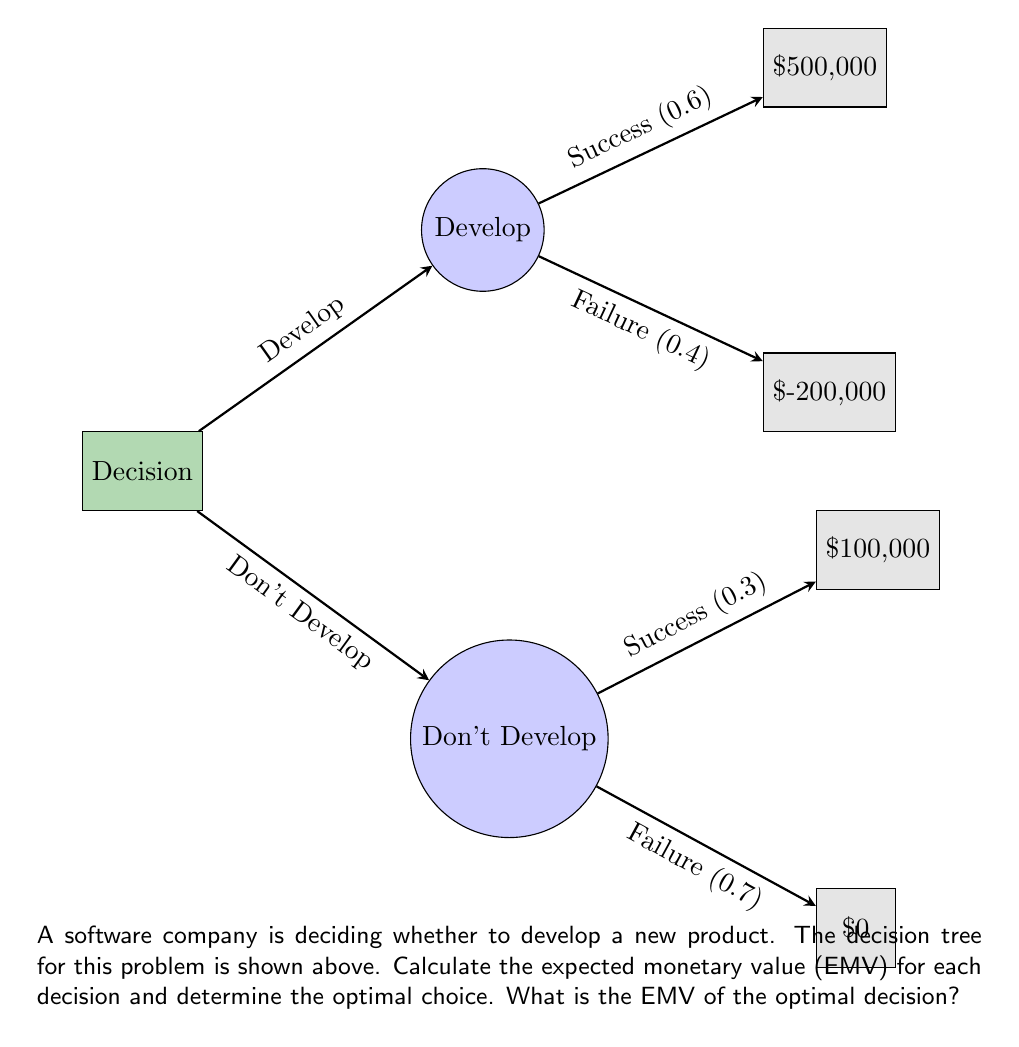Show me your answer to this math problem. Let's solve this problem step by step using the decision tree analysis:

1) First, we need to calculate the EMV for the "Develop" branch:

   a) If they develop and succeed (probability 0.6):
      EMV = $500,000 * 0.6 = $300,000

   b) If they develop and fail (probability 0.4):
      EMV = $-200,000 * 0.4 = $-80,000

   c) Total EMV for "Develop":
      EMV(Develop) = $300,000 + $-80,000 = $220,000

2) Now, let's calculate the EMV for the "Don't Develop" branch:

   a) If they don't develop and would have succeeded (probability 0.3):
      EMV = $100,000 * 0.3 = $30,000

   b) If they don't develop and would have failed (probability 0.7):
      EMV = $0 * 0.7 = $0

   c) Total EMV for "Don't Develop":
      EMV(Don't Develop) = $30,000 + $0 = $30,000

3) Compare the EMVs:
   EMV(Develop) = $220,000
   EMV(Don't Develop) = $30,000

4) The optimal decision is the one with the higher EMV, which is to Develop.

Therefore, the EMV of the optimal decision is $220,000.
Answer: $220,000 